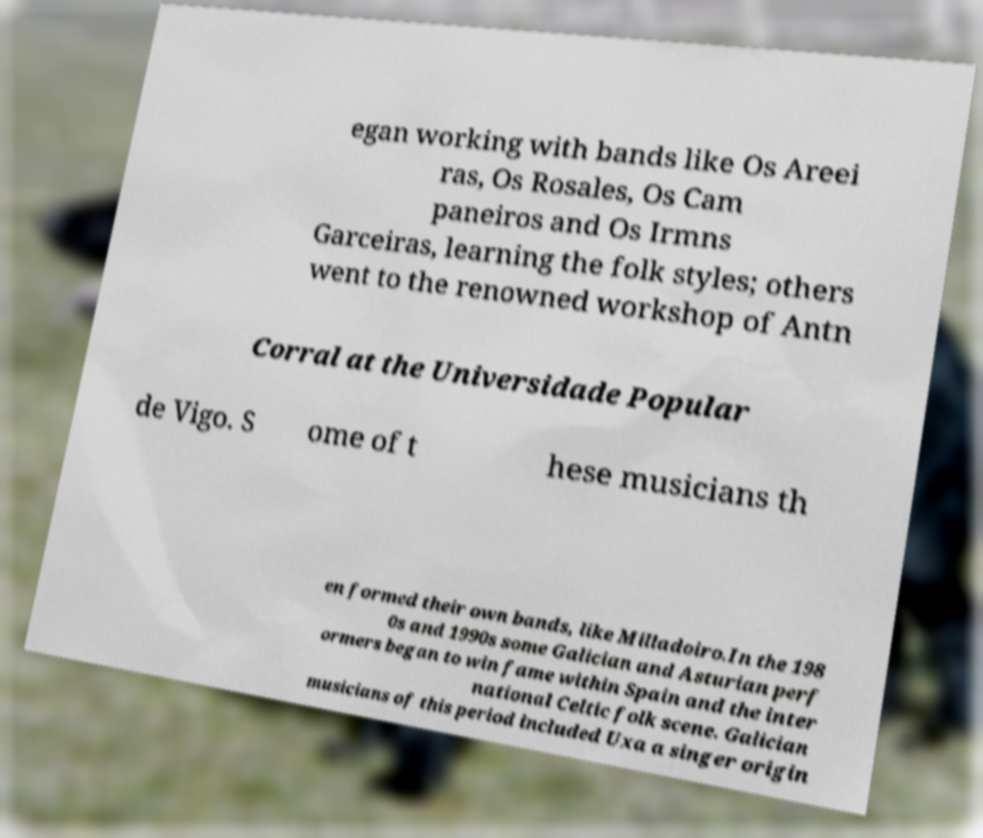Could you extract and type out the text from this image? egan working with bands like Os Areei ras, Os Rosales, Os Cam paneiros and Os Irmns Garceiras, learning the folk styles; others went to the renowned workshop of Antn Corral at the Universidade Popular de Vigo. S ome of t hese musicians th en formed their own bands, like Milladoiro.In the 198 0s and 1990s some Galician and Asturian perf ormers began to win fame within Spain and the inter national Celtic folk scene. Galician musicians of this period included Uxa a singer origin 